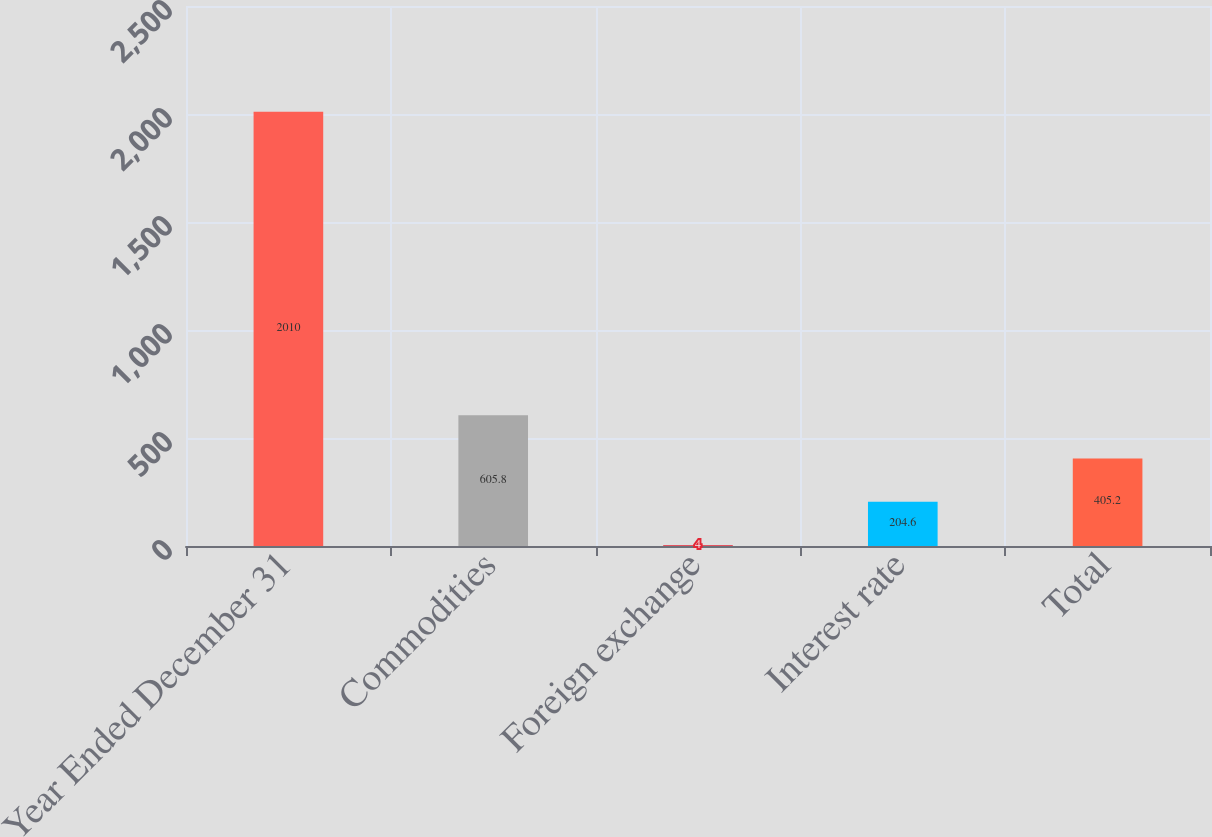<chart> <loc_0><loc_0><loc_500><loc_500><bar_chart><fcel>Year Ended December 31<fcel>Commodities<fcel>Foreign exchange<fcel>Interest rate<fcel>Total<nl><fcel>2010<fcel>605.8<fcel>4<fcel>204.6<fcel>405.2<nl></chart> 